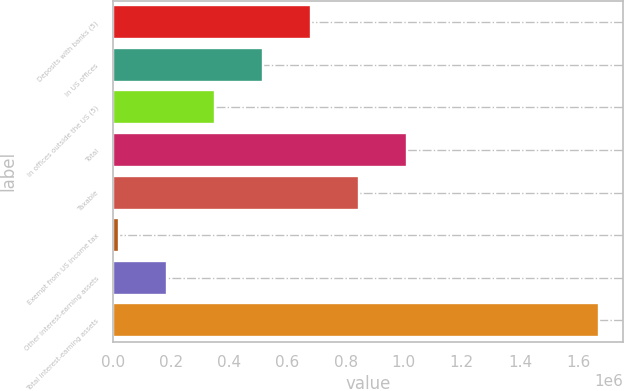Convert chart. <chart><loc_0><loc_0><loc_500><loc_500><bar_chart><fcel>Deposits with banks (5)<fcel>In US offices<fcel>In offices outside the US (5)<fcel>Total<fcel>Taxable<fcel>Exempt from US income tax<fcel>Other interest-earning assets<fcel>Total interest-earning assets<nl><fcel>681109<fcel>515928<fcel>350748<fcel>1.01147e+06<fcel>846290<fcel>20386<fcel>185567<fcel>1.67219e+06<nl></chart> 